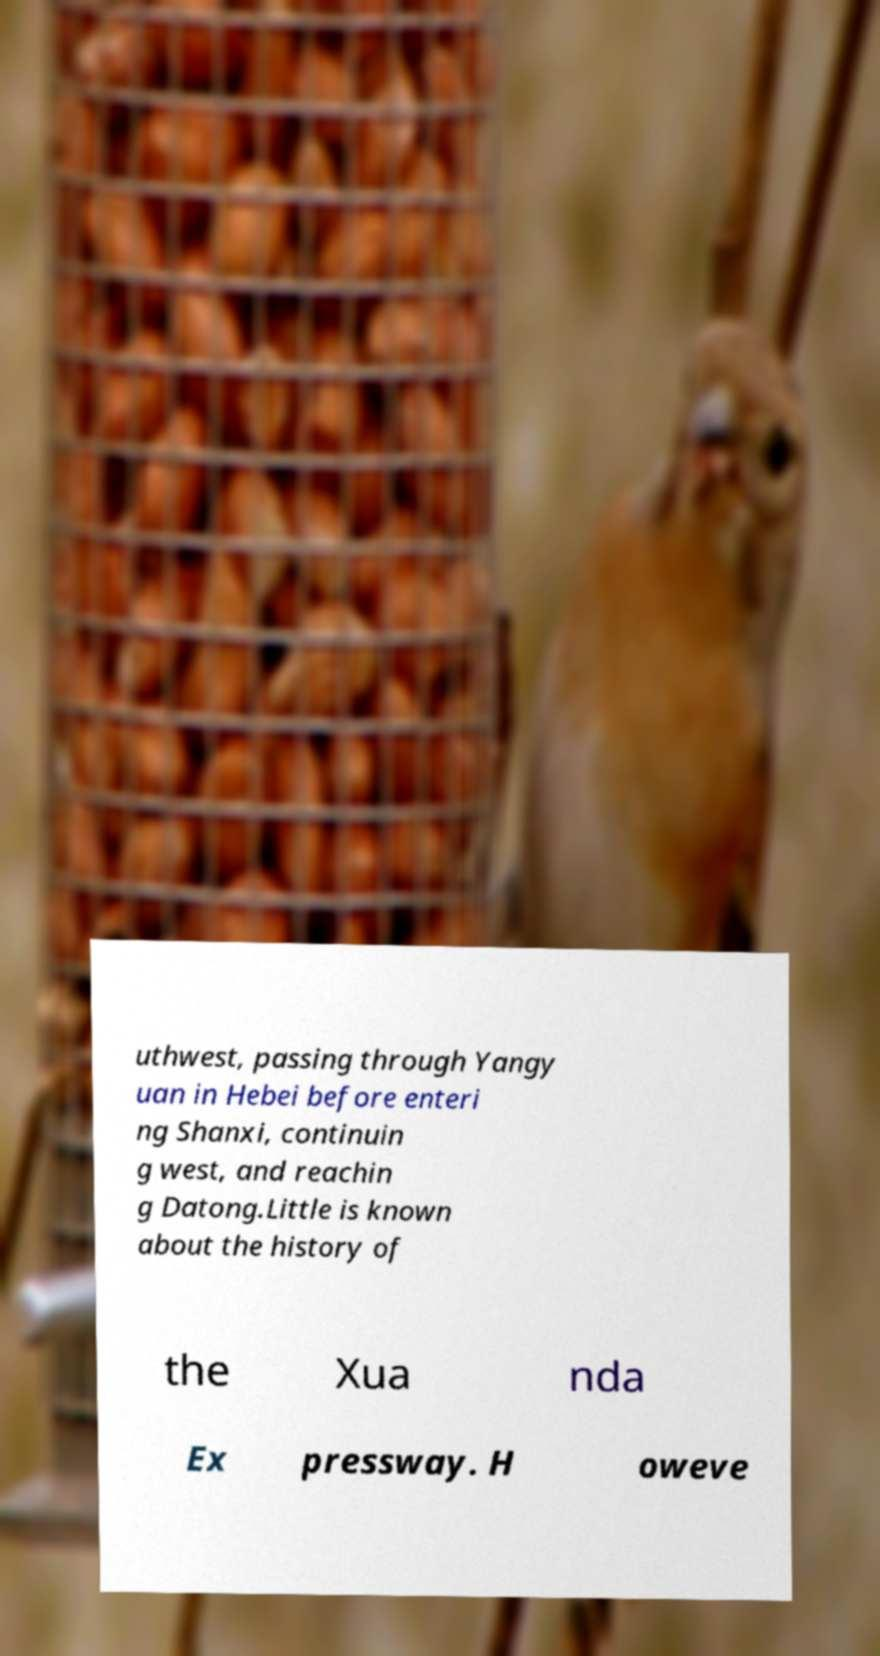Please read and relay the text visible in this image. What does it say? uthwest, passing through Yangy uan in Hebei before enteri ng Shanxi, continuin g west, and reachin g Datong.Little is known about the history of the Xua nda Ex pressway. H oweve 